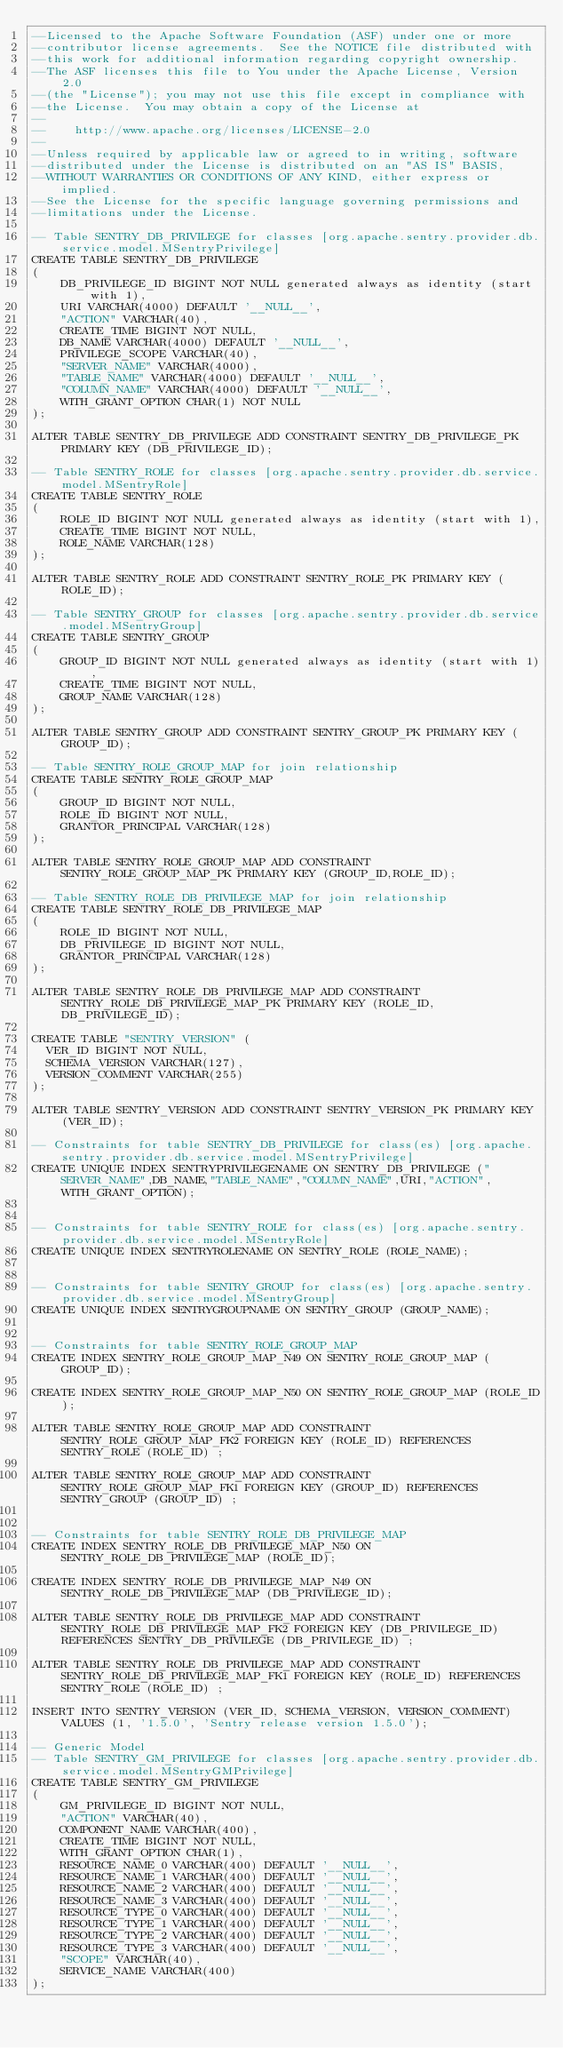Convert code to text. <code><loc_0><loc_0><loc_500><loc_500><_SQL_>--Licensed to the Apache Software Foundation (ASF) under one or more
--contributor license agreements.  See the NOTICE file distributed with
--this work for additional information regarding copyright ownership.
--The ASF licenses this file to You under the Apache License, Version 2.0
--(the "License"); you may not use this file except in compliance with
--the License.  You may obtain a copy of the License at
--
--    http://www.apache.org/licenses/LICENSE-2.0
--
--Unless required by applicable law or agreed to in writing, software
--distributed under the License is distributed on an "AS IS" BASIS,
--WITHOUT WARRANTIES OR CONDITIONS OF ANY KIND, either express or implied.
--See the License for the specific language governing permissions and
--limitations under the License.

-- Table SENTRY_DB_PRIVILEGE for classes [org.apache.sentry.provider.db.service.model.MSentryPrivilege]
CREATE TABLE SENTRY_DB_PRIVILEGE
(
    DB_PRIVILEGE_ID BIGINT NOT NULL generated always as identity (start with 1),
    URI VARCHAR(4000) DEFAULT '__NULL__',
    "ACTION" VARCHAR(40),
    CREATE_TIME BIGINT NOT NULL,
    DB_NAME VARCHAR(4000) DEFAULT '__NULL__',
    PRIVILEGE_SCOPE VARCHAR(40),
    "SERVER_NAME" VARCHAR(4000),
    "TABLE_NAME" VARCHAR(4000) DEFAULT '__NULL__',
    "COLUMN_NAME" VARCHAR(4000) DEFAULT '__NULL__',
    WITH_GRANT_OPTION CHAR(1) NOT NULL
);

ALTER TABLE SENTRY_DB_PRIVILEGE ADD CONSTRAINT SENTRY_DB_PRIVILEGE_PK PRIMARY KEY (DB_PRIVILEGE_ID);

-- Table SENTRY_ROLE for classes [org.apache.sentry.provider.db.service.model.MSentryRole]
CREATE TABLE SENTRY_ROLE
(
    ROLE_ID BIGINT NOT NULL generated always as identity (start with 1),
    CREATE_TIME BIGINT NOT NULL,
    ROLE_NAME VARCHAR(128)
);

ALTER TABLE SENTRY_ROLE ADD CONSTRAINT SENTRY_ROLE_PK PRIMARY KEY (ROLE_ID);

-- Table SENTRY_GROUP for classes [org.apache.sentry.provider.db.service.model.MSentryGroup]
CREATE TABLE SENTRY_GROUP
(
    GROUP_ID BIGINT NOT NULL generated always as identity (start with 1),
    CREATE_TIME BIGINT NOT NULL,
    GROUP_NAME VARCHAR(128)
);

ALTER TABLE SENTRY_GROUP ADD CONSTRAINT SENTRY_GROUP_PK PRIMARY KEY (GROUP_ID);

-- Table SENTRY_ROLE_GROUP_MAP for join relationship
CREATE TABLE SENTRY_ROLE_GROUP_MAP
(
    GROUP_ID BIGINT NOT NULL,
    ROLE_ID BIGINT NOT NULL,
    GRANTOR_PRINCIPAL VARCHAR(128)
);

ALTER TABLE SENTRY_ROLE_GROUP_MAP ADD CONSTRAINT SENTRY_ROLE_GROUP_MAP_PK PRIMARY KEY (GROUP_ID,ROLE_ID);

-- Table SENTRY_ROLE_DB_PRIVILEGE_MAP for join relationship
CREATE TABLE SENTRY_ROLE_DB_PRIVILEGE_MAP
(
    ROLE_ID BIGINT NOT NULL,
    DB_PRIVILEGE_ID BIGINT NOT NULL,
    GRANTOR_PRINCIPAL VARCHAR(128)
);

ALTER TABLE SENTRY_ROLE_DB_PRIVILEGE_MAP ADD CONSTRAINT SENTRY_ROLE_DB_PRIVILEGE_MAP_PK PRIMARY KEY (ROLE_ID,DB_PRIVILEGE_ID);

CREATE TABLE "SENTRY_VERSION" (
  VER_ID BIGINT NOT NULL,
  SCHEMA_VERSION VARCHAR(127),
  VERSION_COMMENT VARCHAR(255)
);

ALTER TABLE SENTRY_VERSION ADD CONSTRAINT SENTRY_VERSION_PK PRIMARY KEY (VER_ID);

-- Constraints for table SENTRY_DB_PRIVILEGE for class(es) [org.apache.sentry.provider.db.service.model.MSentryPrivilege]
CREATE UNIQUE INDEX SENTRYPRIVILEGENAME ON SENTRY_DB_PRIVILEGE ("SERVER_NAME",DB_NAME,"TABLE_NAME","COLUMN_NAME",URI,"ACTION",WITH_GRANT_OPTION);


-- Constraints for table SENTRY_ROLE for class(es) [org.apache.sentry.provider.db.service.model.MSentryRole]
CREATE UNIQUE INDEX SENTRYROLENAME ON SENTRY_ROLE (ROLE_NAME);


-- Constraints for table SENTRY_GROUP for class(es) [org.apache.sentry.provider.db.service.model.MSentryGroup]
CREATE UNIQUE INDEX SENTRYGROUPNAME ON SENTRY_GROUP (GROUP_NAME);


-- Constraints for table SENTRY_ROLE_GROUP_MAP
CREATE INDEX SENTRY_ROLE_GROUP_MAP_N49 ON SENTRY_ROLE_GROUP_MAP (GROUP_ID);

CREATE INDEX SENTRY_ROLE_GROUP_MAP_N50 ON SENTRY_ROLE_GROUP_MAP (ROLE_ID);

ALTER TABLE SENTRY_ROLE_GROUP_MAP ADD CONSTRAINT SENTRY_ROLE_GROUP_MAP_FK2 FOREIGN KEY (ROLE_ID) REFERENCES SENTRY_ROLE (ROLE_ID) ;

ALTER TABLE SENTRY_ROLE_GROUP_MAP ADD CONSTRAINT SENTRY_ROLE_GROUP_MAP_FK1 FOREIGN KEY (GROUP_ID) REFERENCES SENTRY_GROUP (GROUP_ID) ;


-- Constraints for table SENTRY_ROLE_DB_PRIVILEGE_MAP
CREATE INDEX SENTRY_ROLE_DB_PRIVILEGE_MAP_N50 ON SENTRY_ROLE_DB_PRIVILEGE_MAP (ROLE_ID);

CREATE INDEX SENTRY_ROLE_DB_PRIVILEGE_MAP_N49 ON SENTRY_ROLE_DB_PRIVILEGE_MAP (DB_PRIVILEGE_ID);

ALTER TABLE SENTRY_ROLE_DB_PRIVILEGE_MAP ADD CONSTRAINT SENTRY_ROLE_DB_PRIVILEGE_MAP_FK2 FOREIGN KEY (DB_PRIVILEGE_ID) REFERENCES SENTRY_DB_PRIVILEGE (DB_PRIVILEGE_ID) ;

ALTER TABLE SENTRY_ROLE_DB_PRIVILEGE_MAP ADD CONSTRAINT SENTRY_ROLE_DB_PRIVILEGE_MAP_FK1 FOREIGN KEY (ROLE_ID) REFERENCES SENTRY_ROLE (ROLE_ID) ;

INSERT INTO SENTRY_VERSION (VER_ID, SCHEMA_VERSION, VERSION_COMMENT) VALUES (1, '1.5.0', 'Sentry release version 1.5.0');

-- Generic Model
-- Table SENTRY_GM_PRIVILEGE for classes [org.apache.sentry.provider.db.service.model.MSentryGMPrivilege]
CREATE TABLE SENTRY_GM_PRIVILEGE
(
    GM_PRIVILEGE_ID BIGINT NOT NULL,
    "ACTION" VARCHAR(40),
    COMPONENT_NAME VARCHAR(400),
    CREATE_TIME BIGINT NOT NULL,
    WITH_GRANT_OPTION CHAR(1),
    RESOURCE_NAME_0 VARCHAR(400) DEFAULT '__NULL__',
    RESOURCE_NAME_1 VARCHAR(400) DEFAULT '__NULL__',
    RESOURCE_NAME_2 VARCHAR(400) DEFAULT '__NULL__',
    RESOURCE_NAME_3 VARCHAR(400) DEFAULT '__NULL__',
    RESOURCE_TYPE_0 VARCHAR(400) DEFAULT '__NULL__',
    RESOURCE_TYPE_1 VARCHAR(400) DEFAULT '__NULL__',
    RESOURCE_TYPE_2 VARCHAR(400) DEFAULT '__NULL__',
    RESOURCE_TYPE_3 VARCHAR(400) DEFAULT '__NULL__',
    "SCOPE" VARCHAR(40),
    SERVICE_NAME VARCHAR(400)
);</code> 